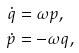<formula> <loc_0><loc_0><loc_500><loc_500>\dot { q } & = \omega p , \\ \dot { p } & = - \omega q ,</formula> 